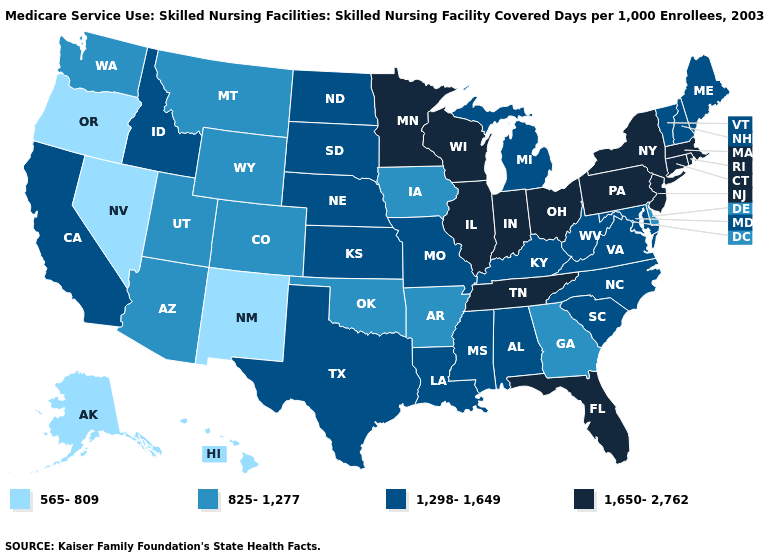Does Alaska have the lowest value in the USA?
Concise answer only. Yes. Name the states that have a value in the range 825-1,277?
Answer briefly. Arizona, Arkansas, Colorado, Delaware, Georgia, Iowa, Montana, Oklahoma, Utah, Washington, Wyoming. What is the value of New Hampshire?
Quick response, please. 1,298-1,649. Does Oklahoma have the lowest value in the South?
Keep it brief. Yes. Among the states that border Wyoming , which have the highest value?
Write a very short answer. Idaho, Nebraska, South Dakota. Name the states that have a value in the range 1,650-2,762?
Concise answer only. Connecticut, Florida, Illinois, Indiana, Massachusetts, Minnesota, New Jersey, New York, Ohio, Pennsylvania, Rhode Island, Tennessee, Wisconsin. What is the value of Georgia?
Give a very brief answer. 825-1,277. What is the value of Wyoming?
Answer briefly. 825-1,277. What is the value of Arkansas?
Short answer required. 825-1,277. What is the value of Oklahoma?
Short answer required. 825-1,277. Name the states that have a value in the range 565-809?
Short answer required. Alaska, Hawaii, Nevada, New Mexico, Oregon. Name the states that have a value in the range 1,650-2,762?
Short answer required. Connecticut, Florida, Illinois, Indiana, Massachusetts, Minnesota, New Jersey, New York, Ohio, Pennsylvania, Rhode Island, Tennessee, Wisconsin. Name the states that have a value in the range 825-1,277?
Give a very brief answer. Arizona, Arkansas, Colorado, Delaware, Georgia, Iowa, Montana, Oklahoma, Utah, Washington, Wyoming. Which states have the lowest value in the West?
Keep it brief. Alaska, Hawaii, Nevada, New Mexico, Oregon. Does the map have missing data?
Short answer required. No. 